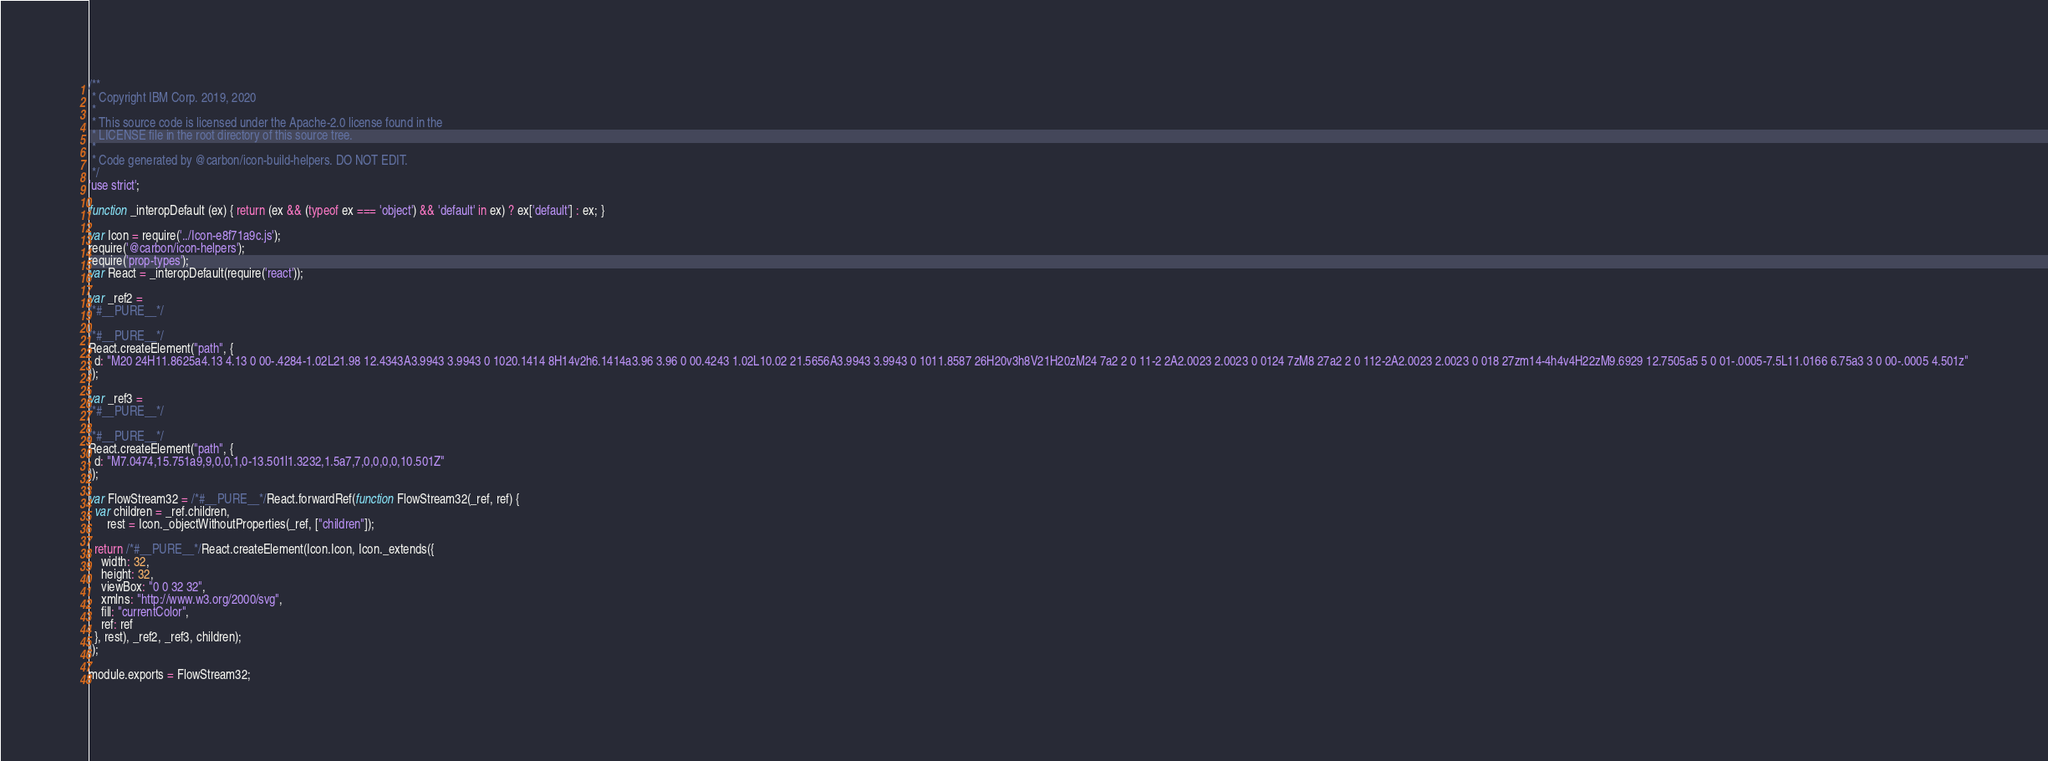Convert code to text. <code><loc_0><loc_0><loc_500><loc_500><_JavaScript_>/**
 * Copyright IBM Corp. 2019, 2020
 *
 * This source code is licensed under the Apache-2.0 license found in the
 * LICENSE file in the root directory of this source tree.
 *
 * Code generated by @carbon/icon-build-helpers. DO NOT EDIT.
 */
'use strict';

function _interopDefault (ex) { return (ex && (typeof ex === 'object') && 'default' in ex) ? ex['default'] : ex; }

var Icon = require('../Icon-e8f71a9c.js');
require('@carbon/icon-helpers');
require('prop-types');
var React = _interopDefault(require('react'));

var _ref2 =
/*#__PURE__*/

/*#__PURE__*/
React.createElement("path", {
  d: "M20 24H11.8625a4.13 4.13 0 00-.4284-1.02L21.98 12.4343A3.9943 3.9943 0 1020.1414 8H14v2h6.1414a3.96 3.96 0 00.4243 1.02L10.02 21.5656A3.9943 3.9943 0 1011.8587 26H20v3h8V21H20zM24 7a2 2 0 11-2 2A2.0023 2.0023 0 0124 7zM8 27a2 2 0 112-2A2.0023 2.0023 0 018 27zm14-4h4v4H22zM9.6929 12.7505a5 5 0 01-.0005-7.5L11.0166 6.75a3 3 0 00-.0005 4.501z"
});

var _ref3 =
/*#__PURE__*/

/*#__PURE__*/
React.createElement("path", {
  d: "M7.0474,15.751a9,9,0,0,1,0-13.501l1.3232,1.5a7,7,0,0,0,0,10.501Z"
});

var FlowStream32 = /*#__PURE__*/React.forwardRef(function FlowStream32(_ref, ref) {
  var children = _ref.children,
      rest = Icon._objectWithoutProperties(_ref, ["children"]);

  return /*#__PURE__*/React.createElement(Icon.Icon, Icon._extends({
    width: 32,
    height: 32,
    viewBox: "0 0 32 32",
    xmlns: "http://www.w3.org/2000/svg",
    fill: "currentColor",
    ref: ref
  }, rest), _ref2, _ref3, children);
});

module.exports = FlowStream32;
</code> 